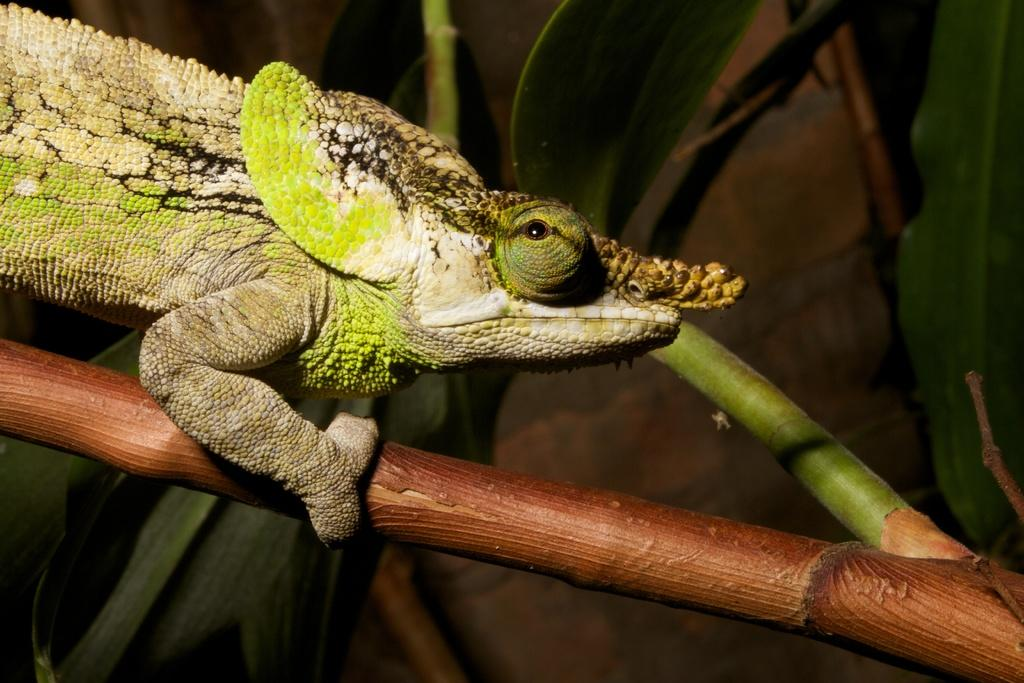What type of animal is in the image? There is a reptile in the image. Can you describe the colors of the reptile? The reptile has green, white, and black colors. Where is the reptile located in the image? The reptile is on a stem. What colors are present in the background of the image? The background of the image is brown and green. What type of record can be seen spinning on the reptile's back in the image? There is no record present in the image; it features a reptile on a stem with a brown and green background. 